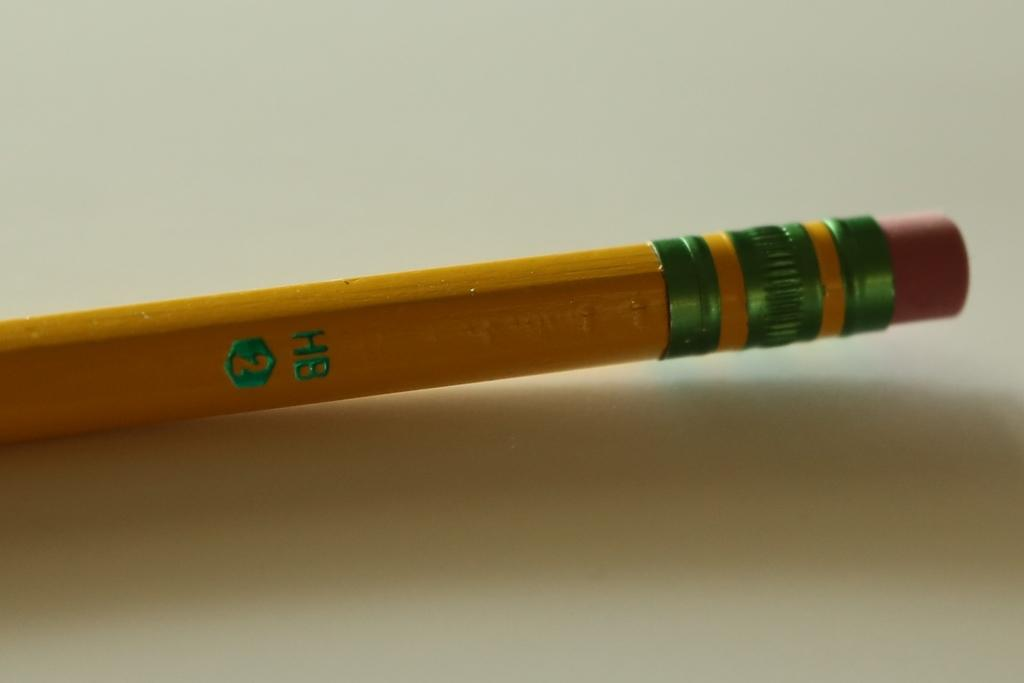<image>
Present a compact description of the photo's key features. A yellow, orangish colored HB #2 pencil with a pink eraser. 